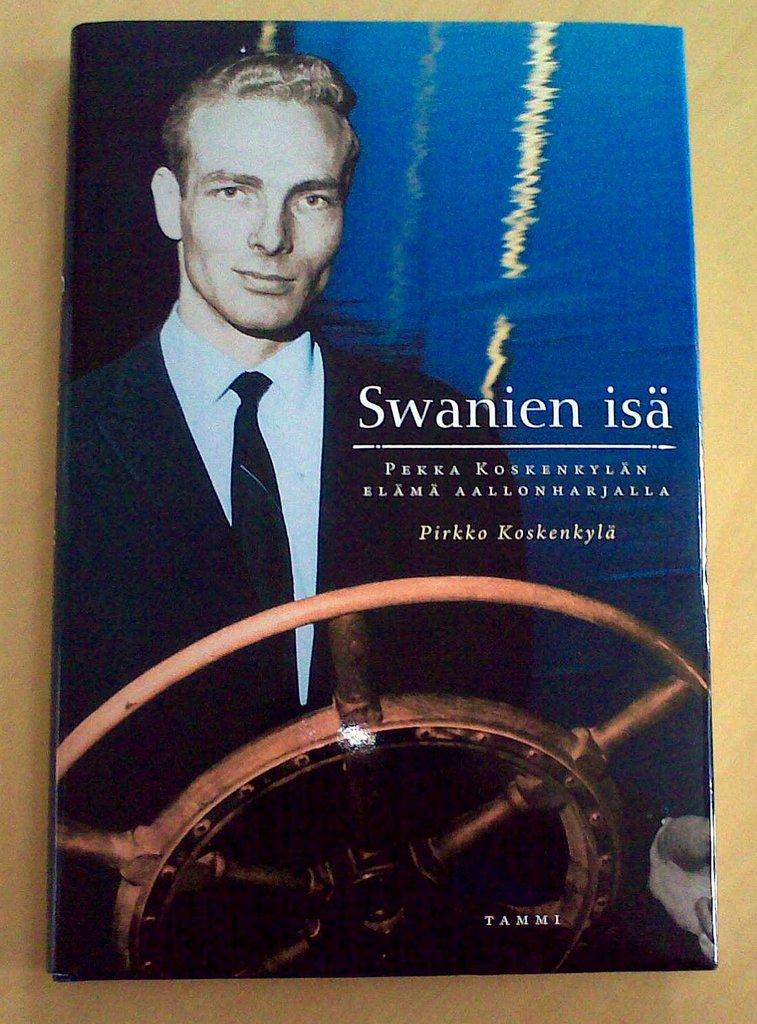<image>
Provide a brief description of the given image. Swanien isa chapter book that is by Pirkko Koskenkyla 